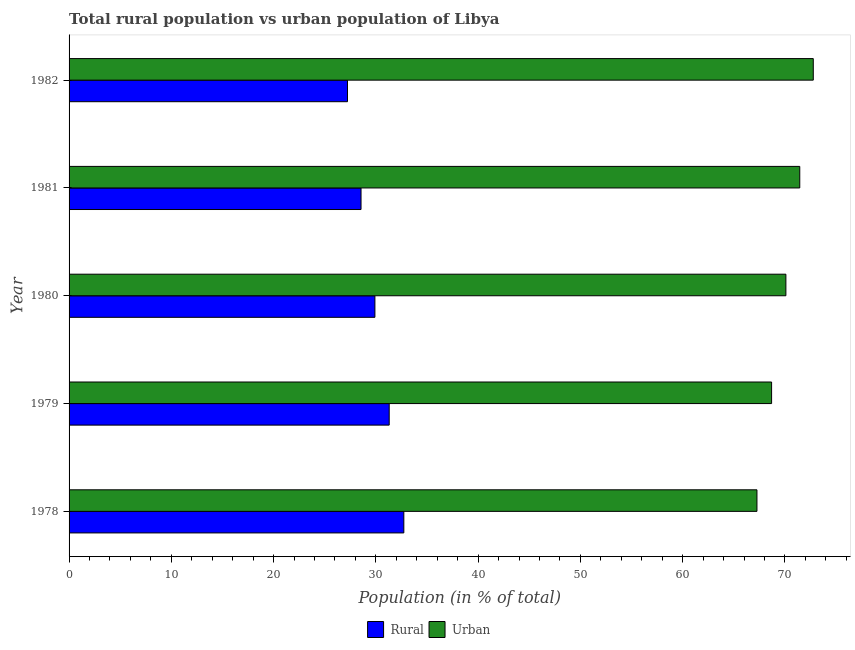How many different coloured bars are there?
Give a very brief answer. 2. What is the label of the 3rd group of bars from the top?
Your response must be concise. 1980. In how many cases, is the number of bars for a given year not equal to the number of legend labels?
Your answer should be very brief. 0. What is the urban population in 1980?
Ensure brevity in your answer.  70.09. Across all years, what is the maximum rural population?
Provide a short and direct response. 32.73. Across all years, what is the minimum rural population?
Offer a very short reply. 27.23. In which year was the rural population maximum?
Provide a succinct answer. 1978. In which year was the urban population minimum?
Offer a terse response. 1978. What is the total urban population in the graph?
Offer a very short reply. 350.28. What is the difference between the rural population in 1978 and that in 1982?
Your answer should be compact. 5.51. What is the difference between the rural population in 1981 and the urban population in 1978?
Provide a succinct answer. -38.72. What is the average rural population per year?
Give a very brief answer. 29.94. In the year 1978, what is the difference between the urban population and rural population?
Offer a terse response. 34.53. In how many years, is the urban population greater than 72 %?
Give a very brief answer. 1. What is the ratio of the urban population in 1978 to that in 1981?
Offer a very short reply. 0.94. Is the difference between the rural population in 1978 and 1981 greater than the difference between the urban population in 1978 and 1981?
Your answer should be very brief. Yes. What is the difference between the highest and the second highest rural population?
Provide a short and direct response. 1.43. What is the difference between the highest and the lowest urban population?
Make the answer very short. 5.51. In how many years, is the rural population greater than the average rural population taken over all years?
Make the answer very short. 2. Is the sum of the rural population in 1978 and 1981 greater than the maximum urban population across all years?
Make the answer very short. No. What does the 2nd bar from the top in 1979 represents?
Your answer should be very brief. Rural. What does the 2nd bar from the bottom in 1978 represents?
Give a very brief answer. Urban. How many bars are there?
Ensure brevity in your answer.  10. Are all the bars in the graph horizontal?
Ensure brevity in your answer.  Yes. What is the difference between two consecutive major ticks on the X-axis?
Provide a succinct answer. 10. How many legend labels are there?
Offer a terse response. 2. How are the legend labels stacked?
Your answer should be compact. Horizontal. What is the title of the graph?
Your response must be concise. Total rural population vs urban population of Libya. What is the label or title of the X-axis?
Offer a terse response. Population (in % of total). What is the Population (in % of total) in Rural in 1978?
Make the answer very short. 32.73. What is the Population (in % of total) in Urban in 1978?
Give a very brief answer. 67.27. What is the Population (in % of total) in Rural in 1979?
Offer a very short reply. 31.3. What is the Population (in % of total) in Urban in 1979?
Offer a terse response. 68.7. What is the Population (in % of total) in Rural in 1980?
Ensure brevity in your answer.  29.91. What is the Population (in % of total) in Urban in 1980?
Provide a succinct answer. 70.09. What is the Population (in % of total) of Rural in 1981?
Your answer should be compact. 28.55. What is the Population (in % of total) of Urban in 1981?
Your response must be concise. 71.45. What is the Population (in % of total) of Rural in 1982?
Ensure brevity in your answer.  27.23. What is the Population (in % of total) in Urban in 1982?
Give a very brief answer. 72.77. Across all years, what is the maximum Population (in % of total) in Rural?
Your answer should be very brief. 32.73. Across all years, what is the maximum Population (in % of total) of Urban?
Your answer should be very brief. 72.77. Across all years, what is the minimum Population (in % of total) in Rural?
Your response must be concise. 27.23. Across all years, what is the minimum Population (in % of total) of Urban?
Give a very brief answer. 67.27. What is the total Population (in % of total) in Rural in the graph?
Give a very brief answer. 149.72. What is the total Population (in % of total) of Urban in the graph?
Ensure brevity in your answer.  350.28. What is the difference between the Population (in % of total) in Rural in 1978 and that in 1979?
Your answer should be very brief. 1.43. What is the difference between the Population (in % of total) in Urban in 1978 and that in 1979?
Provide a short and direct response. -1.43. What is the difference between the Population (in % of total) of Rural in 1978 and that in 1980?
Provide a succinct answer. 2.83. What is the difference between the Population (in % of total) in Urban in 1978 and that in 1980?
Provide a short and direct response. -2.83. What is the difference between the Population (in % of total) in Rural in 1978 and that in 1981?
Ensure brevity in your answer.  4.19. What is the difference between the Population (in % of total) in Urban in 1978 and that in 1981?
Your answer should be very brief. -4.19. What is the difference between the Population (in % of total) of Rural in 1978 and that in 1982?
Offer a terse response. 5.51. What is the difference between the Population (in % of total) of Urban in 1978 and that in 1982?
Keep it short and to the point. -5.51. What is the difference between the Population (in % of total) of Rural in 1979 and that in 1980?
Keep it short and to the point. 1.4. What is the difference between the Population (in % of total) in Urban in 1979 and that in 1980?
Offer a very short reply. -1.4. What is the difference between the Population (in % of total) in Rural in 1979 and that in 1981?
Give a very brief answer. 2.75. What is the difference between the Population (in % of total) of Urban in 1979 and that in 1981?
Provide a succinct answer. -2.75. What is the difference between the Population (in % of total) in Rural in 1979 and that in 1982?
Provide a short and direct response. 4.08. What is the difference between the Population (in % of total) in Urban in 1979 and that in 1982?
Offer a very short reply. -4.08. What is the difference between the Population (in % of total) in Rural in 1980 and that in 1981?
Your answer should be very brief. 1.36. What is the difference between the Population (in % of total) of Urban in 1980 and that in 1981?
Keep it short and to the point. -1.36. What is the difference between the Population (in % of total) of Rural in 1980 and that in 1982?
Offer a terse response. 2.68. What is the difference between the Population (in % of total) of Urban in 1980 and that in 1982?
Your response must be concise. -2.68. What is the difference between the Population (in % of total) of Rural in 1981 and that in 1982?
Your answer should be very brief. 1.32. What is the difference between the Population (in % of total) of Urban in 1981 and that in 1982?
Provide a succinct answer. -1.32. What is the difference between the Population (in % of total) of Rural in 1978 and the Population (in % of total) of Urban in 1979?
Your answer should be very brief. -35.96. What is the difference between the Population (in % of total) of Rural in 1978 and the Population (in % of total) of Urban in 1980?
Offer a very short reply. -37.36. What is the difference between the Population (in % of total) of Rural in 1978 and the Population (in % of total) of Urban in 1981?
Your response must be concise. -38.72. What is the difference between the Population (in % of total) of Rural in 1978 and the Population (in % of total) of Urban in 1982?
Offer a very short reply. -40.04. What is the difference between the Population (in % of total) in Rural in 1979 and the Population (in % of total) in Urban in 1980?
Your response must be concise. -38.79. What is the difference between the Population (in % of total) in Rural in 1979 and the Population (in % of total) in Urban in 1981?
Offer a very short reply. -40.15. What is the difference between the Population (in % of total) of Rural in 1979 and the Population (in % of total) of Urban in 1982?
Ensure brevity in your answer.  -41.47. What is the difference between the Population (in % of total) in Rural in 1980 and the Population (in % of total) in Urban in 1981?
Make the answer very short. -41.55. What is the difference between the Population (in % of total) in Rural in 1980 and the Population (in % of total) in Urban in 1982?
Offer a terse response. -42.87. What is the difference between the Population (in % of total) of Rural in 1981 and the Population (in % of total) of Urban in 1982?
Offer a very short reply. -44.22. What is the average Population (in % of total) in Rural per year?
Ensure brevity in your answer.  29.94. What is the average Population (in % of total) in Urban per year?
Offer a terse response. 70.06. In the year 1978, what is the difference between the Population (in % of total) in Rural and Population (in % of total) in Urban?
Provide a succinct answer. -34.53. In the year 1979, what is the difference between the Population (in % of total) of Rural and Population (in % of total) of Urban?
Give a very brief answer. -37.39. In the year 1980, what is the difference between the Population (in % of total) in Rural and Population (in % of total) in Urban?
Offer a terse response. -40.19. In the year 1981, what is the difference between the Population (in % of total) of Rural and Population (in % of total) of Urban?
Ensure brevity in your answer.  -42.9. In the year 1982, what is the difference between the Population (in % of total) of Rural and Population (in % of total) of Urban?
Ensure brevity in your answer.  -45.55. What is the ratio of the Population (in % of total) in Rural in 1978 to that in 1979?
Make the answer very short. 1.05. What is the ratio of the Population (in % of total) of Urban in 1978 to that in 1979?
Offer a very short reply. 0.98. What is the ratio of the Population (in % of total) of Rural in 1978 to that in 1980?
Keep it short and to the point. 1.09. What is the ratio of the Population (in % of total) of Urban in 1978 to that in 1980?
Keep it short and to the point. 0.96. What is the ratio of the Population (in % of total) in Rural in 1978 to that in 1981?
Ensure brevity in your answer.  1.15. What is the ratio of the Population (in % of total) in Urban in 1978 to that in 1981?
Ensure brevity in your answer.  0.94. What is the ratio of the Population (in % of total) of Rural in 1978 to that in 1982?
Provide a short and direct response. 1.2. What is the ratio of the Population (in % of total) in Urban in 1978 to that in 1982?
Provide a succinct answer. 0.92. What is the ratio of the Population (in % of total) of Rural in 1979 to that in 1980?
Ensure brevity in your answer.  1.05. What is the ratio of the Population (in % of total) of Urban in 1979 to that in 1980?
Give a very brief answer. 0.98. What is the ratio of the Population (in % of total) of Rural in 1979 to that in 1981?
Make the answer very short. 1.1. What is the ratio of the Population (in % of total) of Urban in 1979 to that in 1981?
Offer a terse response. 0.96. What is the ratio of the Population (in % of total) in Rural in 1979 to that in 1982?
Your answer should be compact. 1.15. What is the ratio of the Population (in % of total) of Urban in 1979 to that in 1982?
Offer a very short reply. 0.94. What is the ratio of the Population (in % of total) in Rural in 1980 to that in 1981?
Provide a succinct answer. 1.05. What is the ratio of the Population (in % of total) of Rural in 1980 to that in 1982?
Provide a succinct answer. 1.1. What is the ratio of the Population (in % of total) in Urban in 1980 to that in 1982?
Your answer should be very brief. 0.96. What is the ratio of the Population (in % of total) of Rural in 1981 to that in 1982?
Provide a short and direct response. 1.05. What is the ratio of the Population (in % of total) of Urban in 1981 to that in 1982?
Give a very brief answer. 0.98. What is the difference between the highest and the second highest Population (in % of total) of Rural?
Keep it short and to the point. 1.43. What is the difference between the highest and the second highest Population (in % of total) of Urban?
Ensure brevity in your answer.  1.32. What is the difference between the highest and the lowest Population (in % of total) of Rural?
Your answer should be compact. 5.51. What is the difference between the highest and the lowest Population (in % of total) in Urban?
Provide a short and direct response. 5.51. 